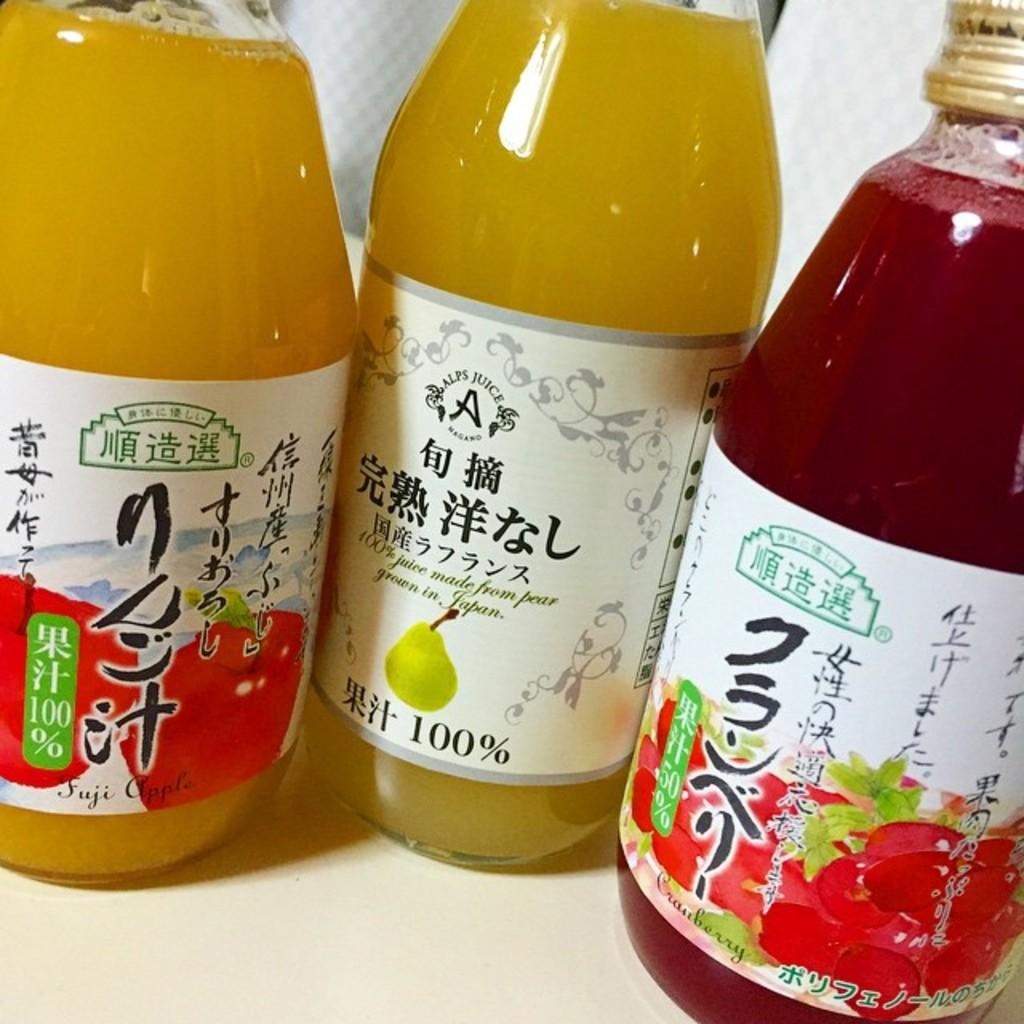How many bottles are visible in the image? There are three bottles in the image. What are the bottles containing? The bottles contain drinks. In which direction are the bottles facing in the image? The direction the bottles are facing cannot be determined from the image, as they are not shown with any specific orientation. 